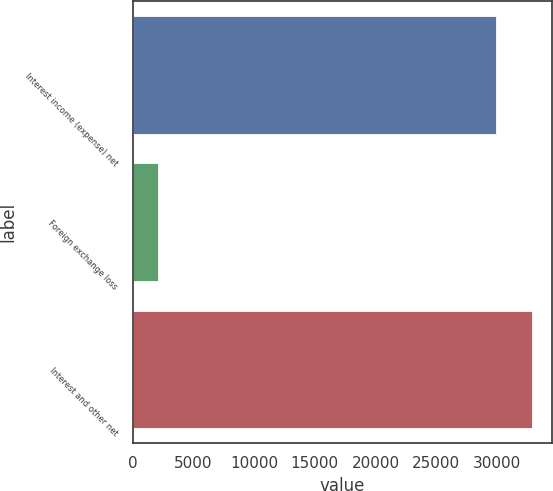Convert chart. <chart><loc_0><loc_0><loc_500><loc_500><bar_chart><fcel>Interest income (expense) net<fcel>Foreign exchange loss<fcel>Interest and other net<nl><fcel>29901<fcel>2068<fcel>32883.5<nl></chart> 